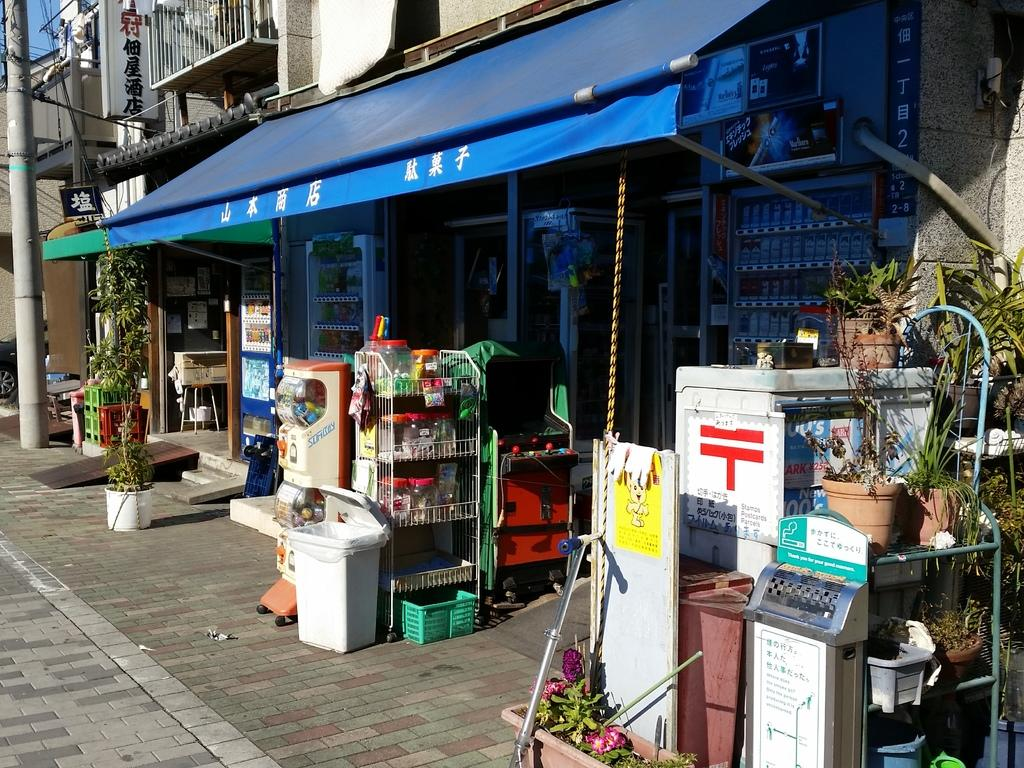<image>
Give a short and clear explanation of the subsequent image. A cigarette dispenser says, "Thank you for your manners" 